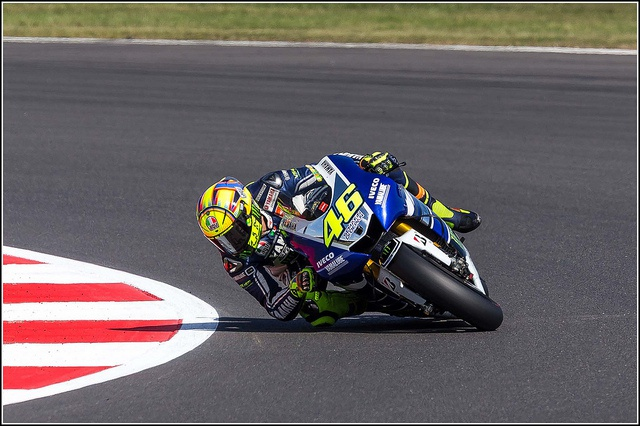Describe the objects in this image and their specific colors. I can see motorcycle in black, gray, navy, and white tones and people in black, gray, navy, and yellow tones in this image. 